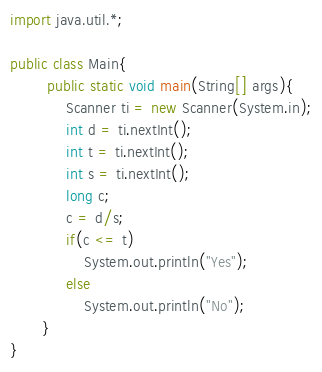<code> <loc_0><loc_0><loc_500><loc_500><_Java_>import java.util.*;

public class Main{
		public static void main(String[] args){
       		Scanner ti = new Scanner(System.in);
            int d = ti.nextInt();
            int t = ti.nextInt();
            int s = ti.nextInt();
          	long c;
           	c = d/s;
            if(c <= t)
     			System.out.println("Yes");
            else
            	System.out.println("No");
       }	
}</code> 